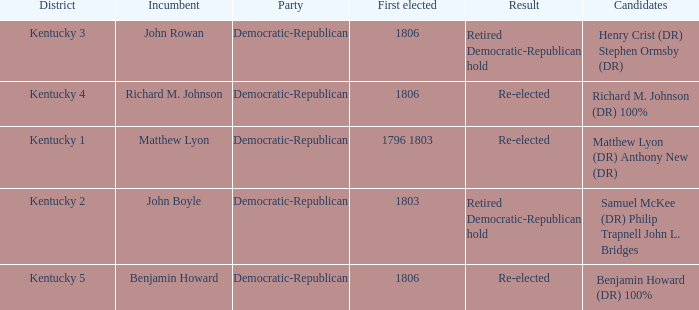Name the candidates for john boyle Samuel McKee (DR) Philip Trapnell John L. Bridges. 